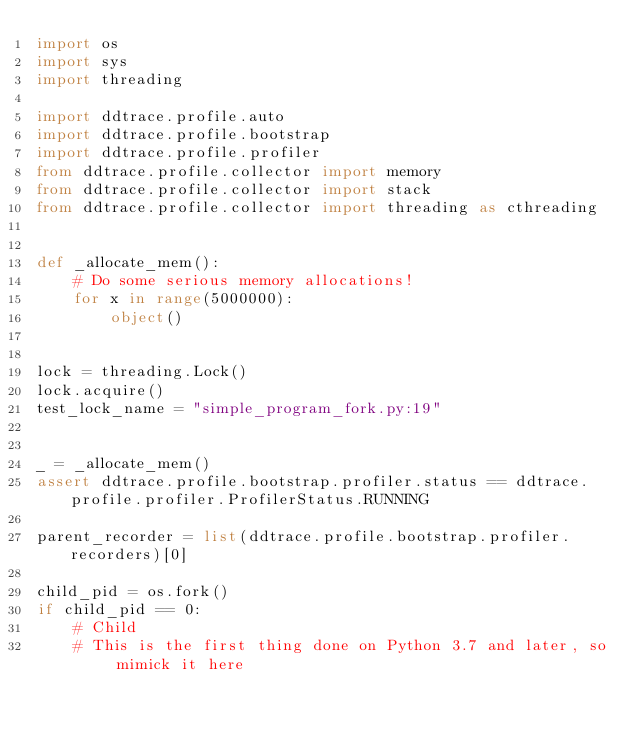<code> <loc_0><loc_0><loc_500><loc_500><_Python_>import os
import sys
import threading

import ddtrace.profile.auto
import ddtrace.profile.bootstrap
import ddtrace.profile.profiler
from ddtrace.profile.collector import memory
from ddtrace.profile.collector import stack
from ddtrace.profile.collector import threading as cthreading


def _allocate_mem():
    # Do some serious memory allocations!
    for x in range(5000000):
        object()


lock = threading.Lock()
lock.acquire()
test_lock_name = "simple_program_fork.py:19"


_ = _allocate_mem()
assert ddtrace.profile.bootstrap.profiler.status == ddtrace.profile.profiler.ProfilerStatus.RUNNING

parent_recorder = list(ddtrace.profile.bootstrap.profiler.recorders)[0]

child_pid = os.fork()
if child_pid == 0:
    # Child
    # This is the first thing done on Python 3.7 and later, so mimick it here</code> 